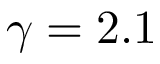Convert formula to latex. <formula><loc_0><loc_0><loc_500><loc_500>\gamma = 2 . 1</formula> 